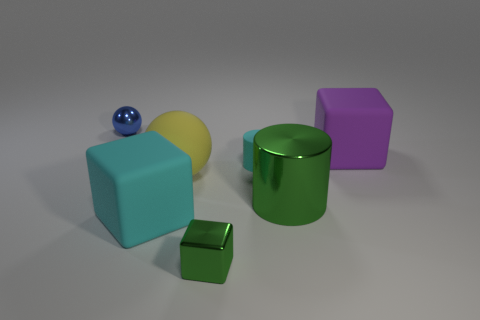Subtract all cylinders. How many objects are left? 5 Add 7 metallic cylinders. How many metallic cylinders exist? 8 Add 1 large green matte cylinders. How many objects exist? 8 Subtract all green blocks. How many blocks are left? 2 Subtract all small shiny blocks. How many blocks are left? 2 Subtract 1 yellow balls. How many objects are left? 6 Subtract 1 cylinders. How many cylinders are left? 1 Subtract all red balls. Subtract all green cylinders. How many balls are left? 2 Subtract all green cubes. How many red cylinders are left? 0 Subtract all big cyan cubes. Subtract all large green shiny cylinders. How many objects are left? 5 